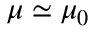Convert formula to latex. <formula><loc_0><loc_0><loc_500><loc_500>\mu \simeq \mu _ { 0 }</formula> 